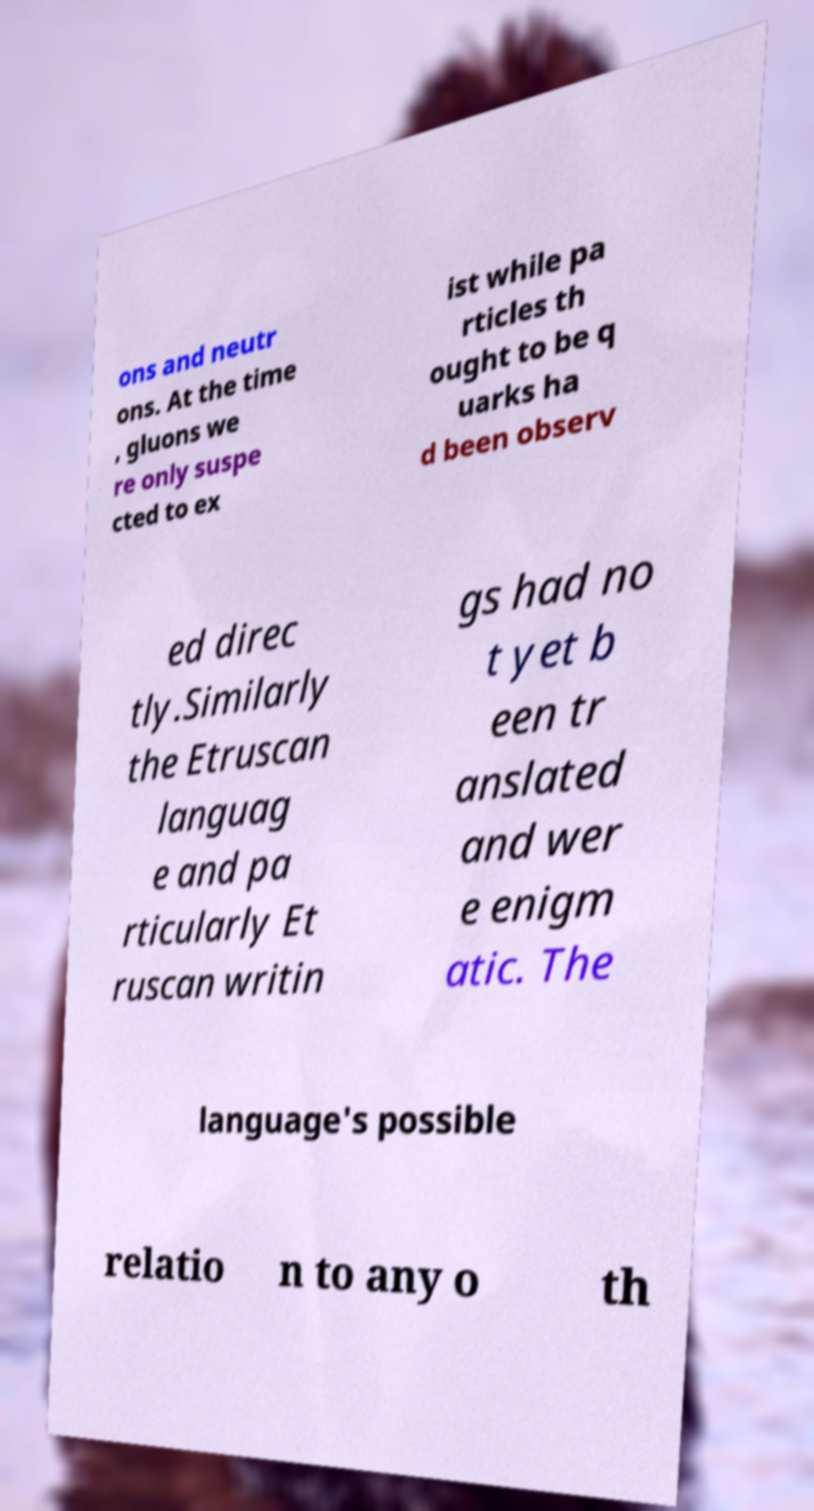Can you accurately transcribe the text from the provided image for me? ons and neutr ons. At the time , gluons we re only suspe cted to ex ist while pa rticles th ought to be q uarks ha d been observ ed direc tly.Similarly the Etruscan languag e and pa rticularly Et ruscan writin gs had no t yet b een tr anslated and wer e enigm atic. The language's possible relatio n to any o th 